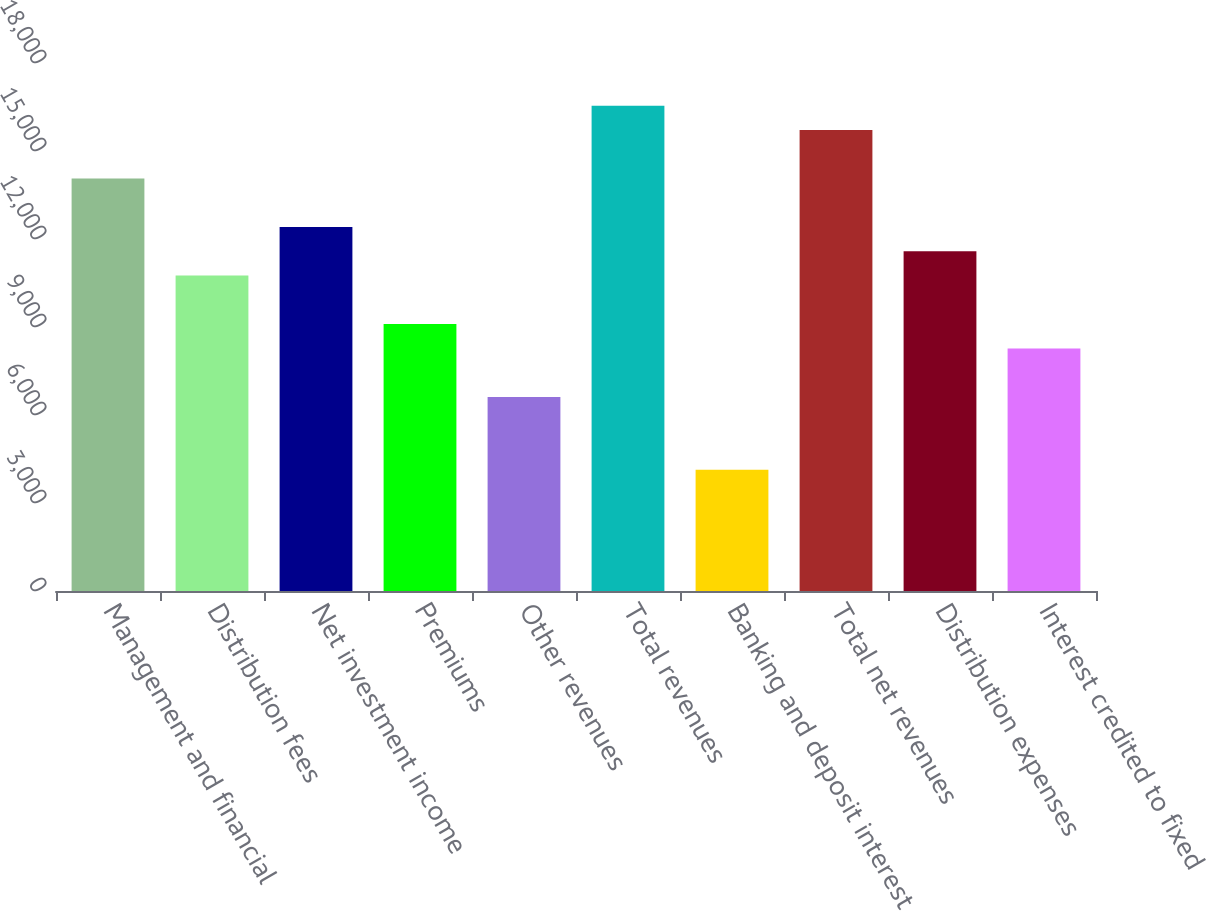<chart> <loc_0><loc_0><loc_500><loc_500><bar_chart><fcel>Management and financial<fcel>Distribution fees<fcel>Net investment income<fcel>Premiums<fcel>Other revenues<fcel>Total revenues<fcel>Banking and deposit interest<fcel>Total net revenues<fcel>Distribution expenses<fcel>Interest credited to fixed<nl><fcel>14060.5<fcel>10752.2<fcel>12406.3<fcel>9098.1<fcel>6616.92<fcel>16541.6<fcel>4135.74<fcel>15714.6<fcel>11579.3<fcel>8271.04<nl></chart> 